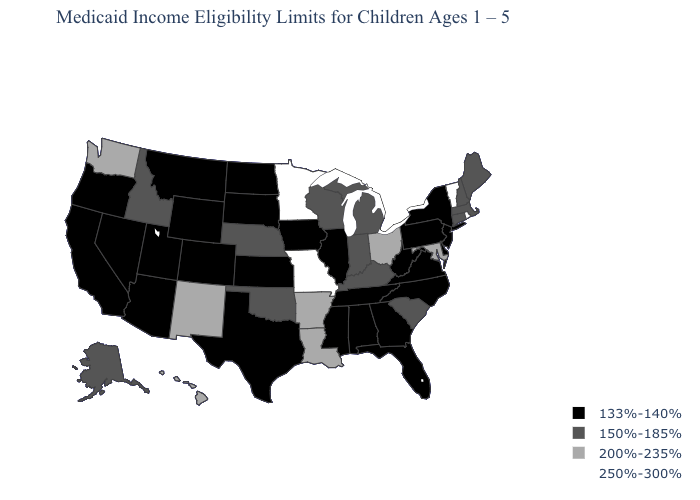What is the value of Missouri?
Keep it brief. 250%-300%. Name the states that have a value in the range 200%-235%?
Give a very brief answer. Arkansas, Hawaii, Louisiana, Maryland, New Mexico, Ohio, Washington. Name the states that have a value in the range 200%-235%?
Concise answer only. Arkansas, Hawaii, Louisiana, Maryland, New Mexico, Ohio, Washington. Does the first symbol in the legend represent the smallest category?
Concise answer only. Yes. Name the states that have a value in the range 150%-185%?
Give a very brief answer. Alaska, Connecticut, Idaho, Indiana, Kentucky, Maine, Massachusetts, Michigan, Nebraska, New Hampshire, Oklahoma, South Carolina, Wisconsin. Among the states that border Massachusetts , does New York have the highest value?
Answer briefly. No. Does the map have missing data?
Write a very short answer. No. Does New Mexico have a higher value than Idaho?
Keep it brief. Yes. What is the lowest value in the MidWest?
Keep it brief. 133%-140%. What is the highest value in states that border Arizona?
Give a very brief answer. 200%-235%. Name the states that have a value in the range 250%-300%?
Keep it brief. Minnesota, Missouri, Rhode Island, Vermont. What is the value of Montana?
Be succinct. 133%-140%. What is the highest value in the USA?
Give a very brief answer. 250%-300%. Among the states that border Oregon , which have the lowest value?
Give a very brief answer. California, Nevada. What is the value of Louisiana?
Write a very short answer. 200%-235%. 